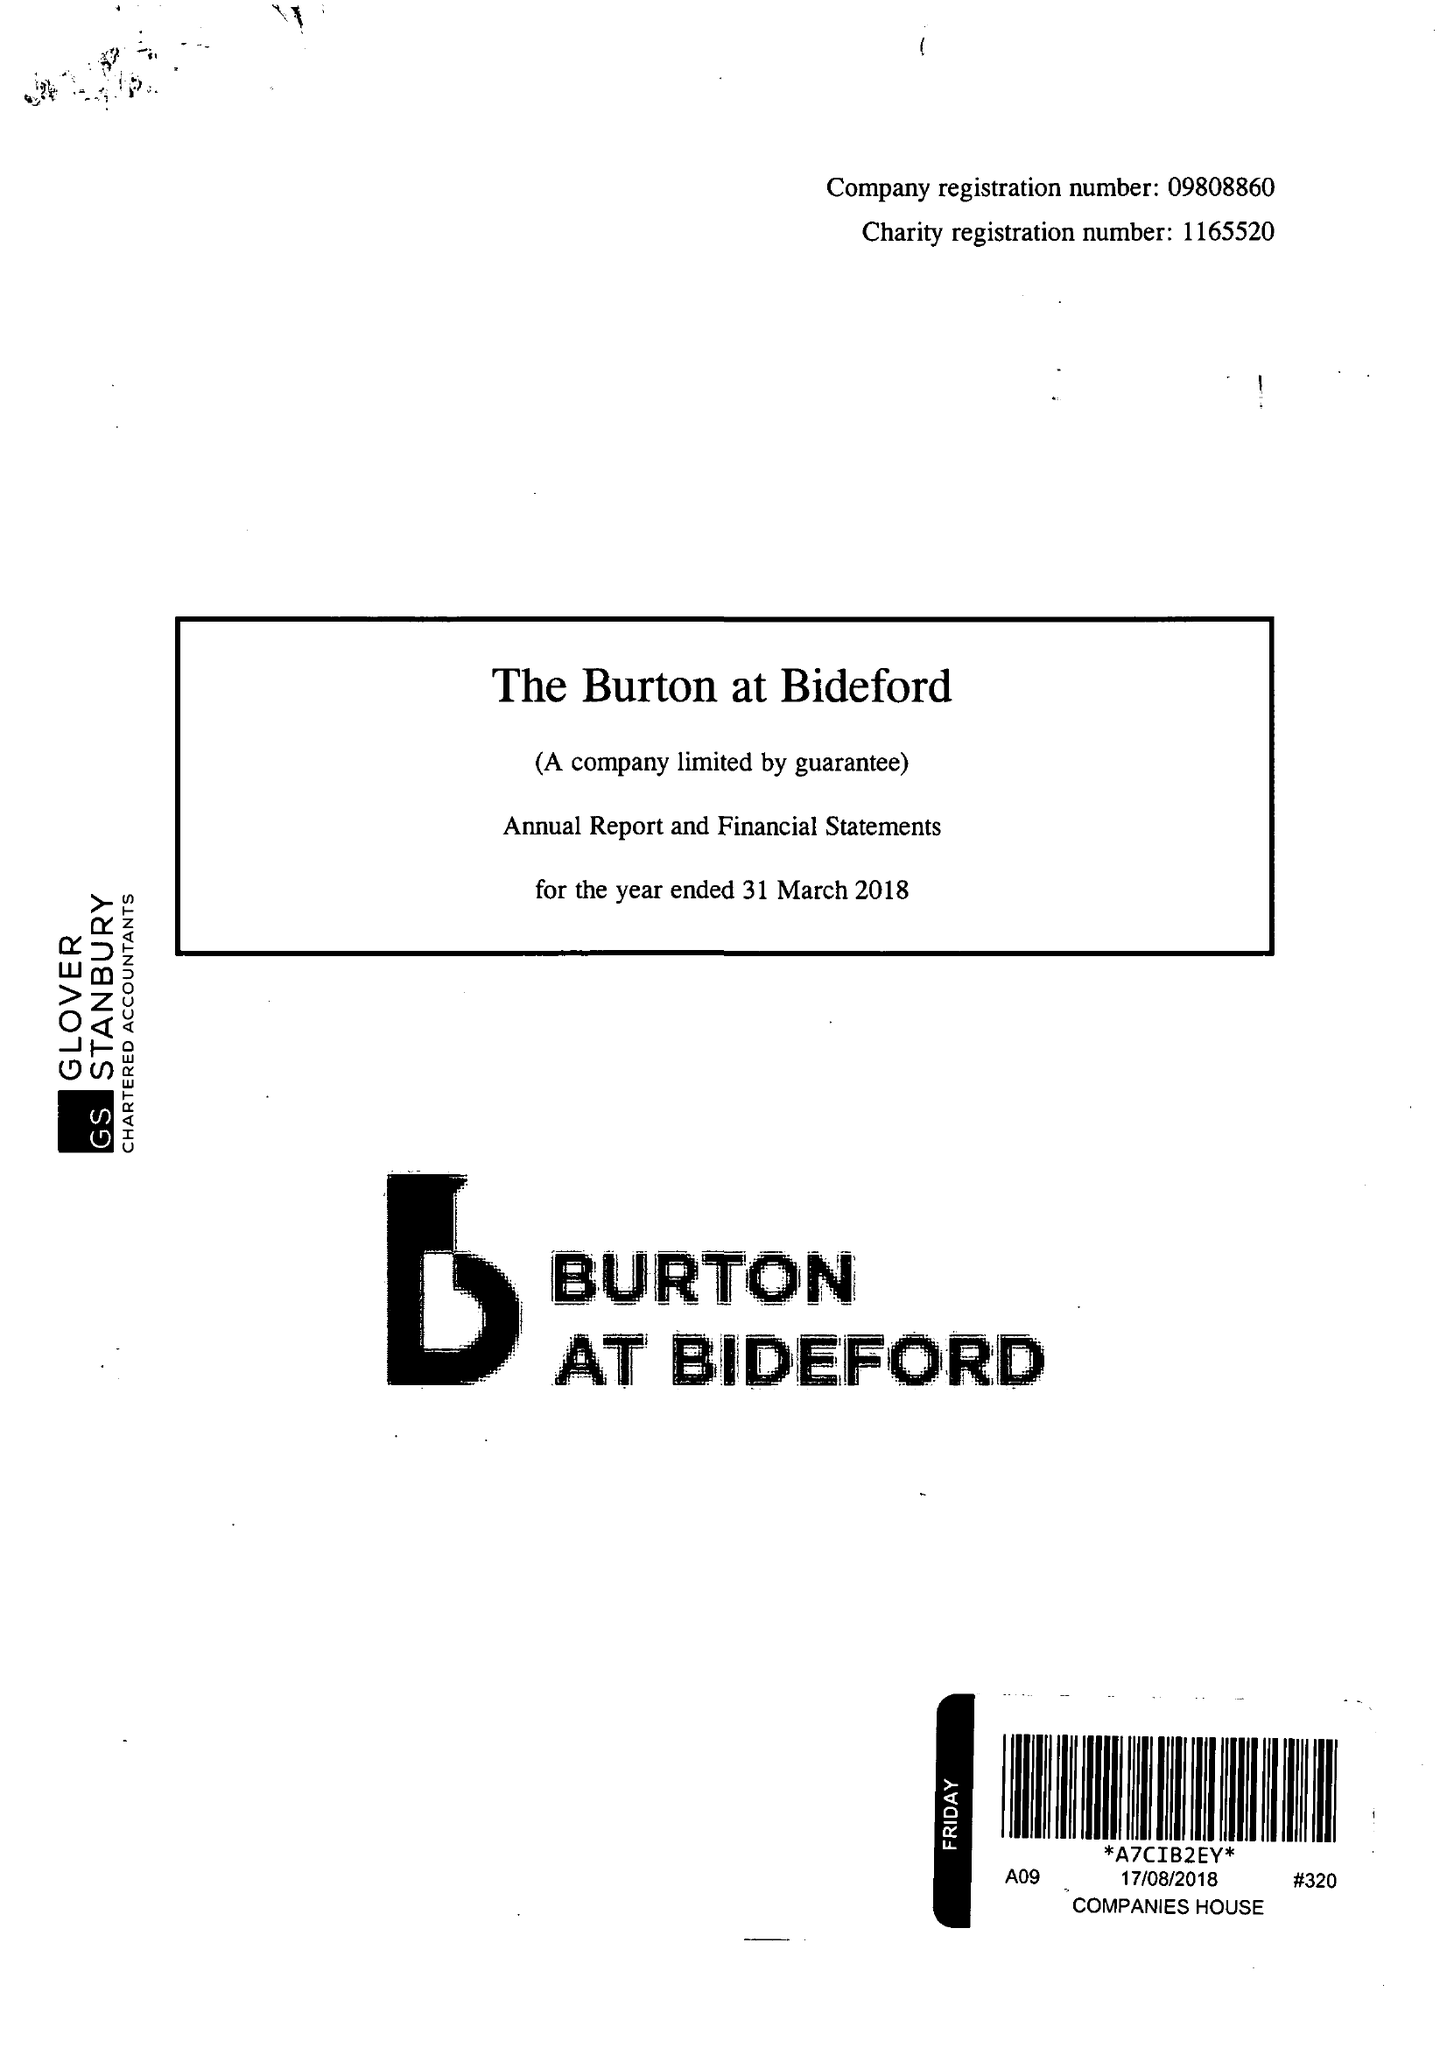What is the value for the charity_name?
Answer the question using a single word or phrase. The Burton At Bideford 